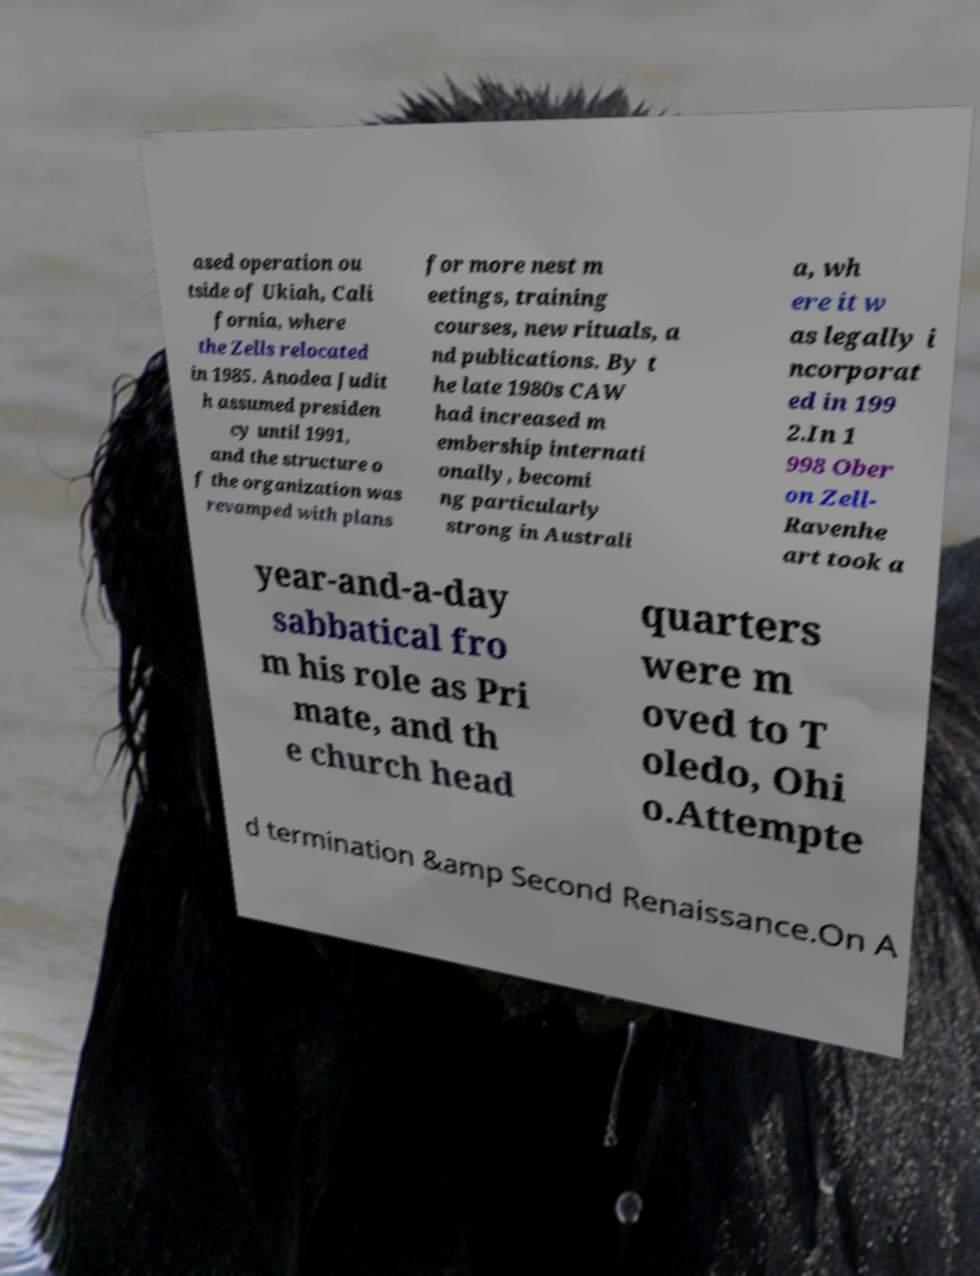What messages or text are displayed in this image? I need them in a readable, typed format. ased operation ou tside of Ukiah, Cali fornia, where the Zells relocated in 1985. Anodea Judit h assumed presiden cy until 1991, and the structure o f the organization was revamped with plans for more nest m eetings, training courses, new rituals, a nd publications. By t he late 1980s CAW had increased m embership internati onally, becomi ng particularly strong in Australi a, wh ere it w as legally i ncorporat ed in 199 2.In 1 998 Ober on Zell- Ravenhe art took a year-and-a-day sabbatical fro m his role as Pri mate, and th e church head quarters were m oved to T oledo, Ohi o.Attempte d termination &amp Second Renaissance.On A 